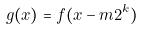<formula> <loc_0><loc_0><loc_500><loc_500>g ( x ) = f ( x - m 2 ^ { k } )</formula> 